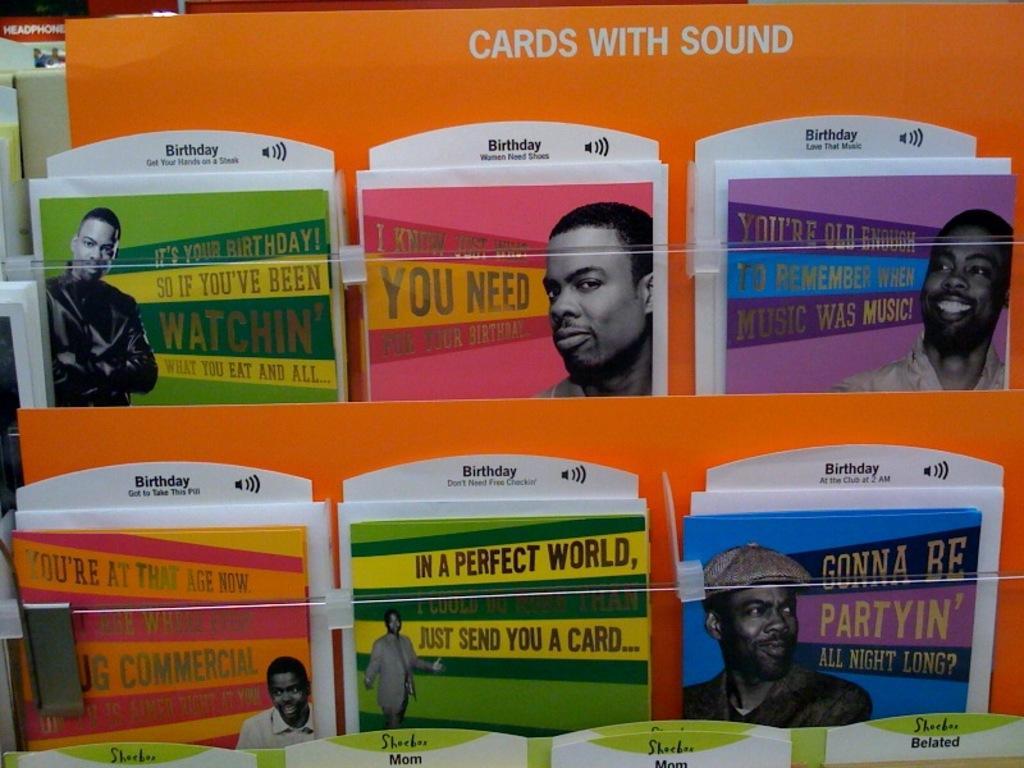Please provide a concise description of this image. In this image we can see cards are arranged in the rows. On the cards we can see the pictures of man and some text. 